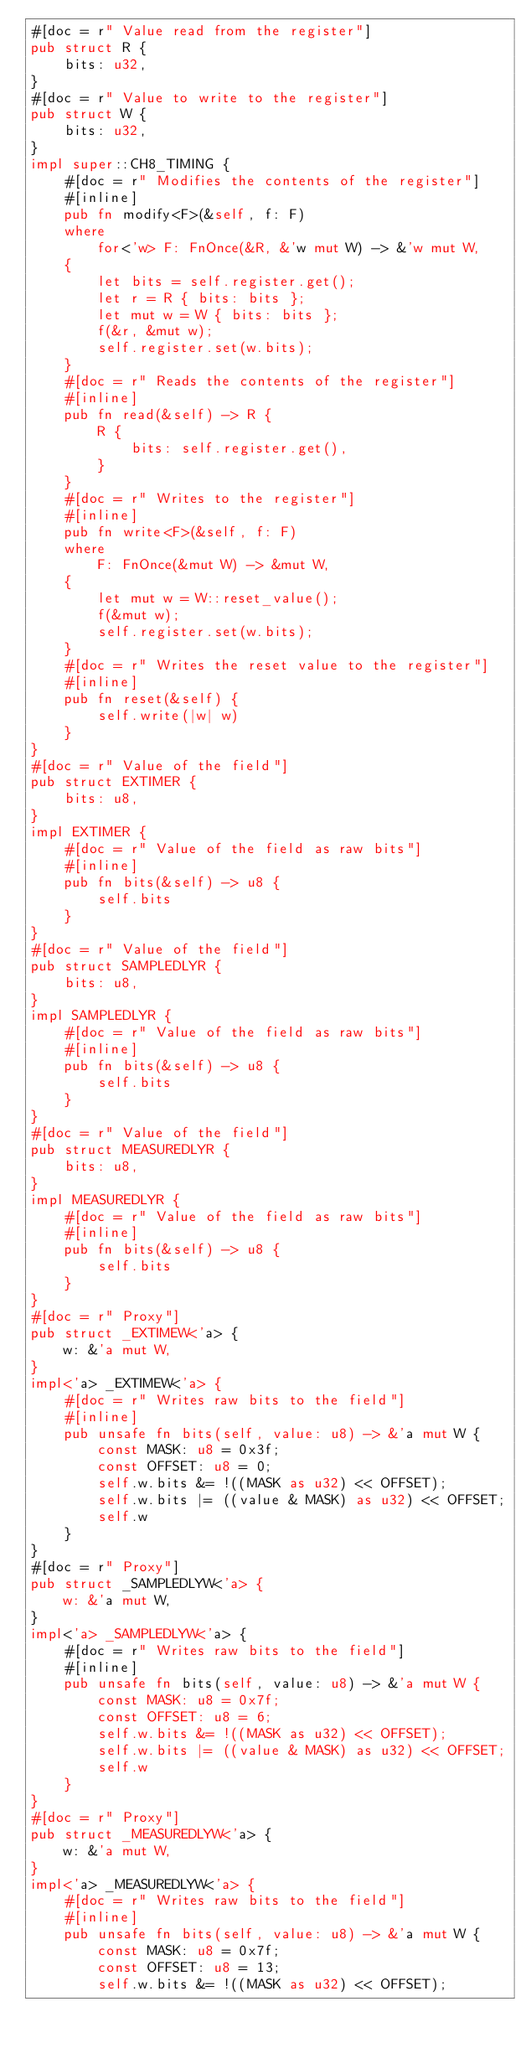Convert code to text. <code><loc_0><loc_0><loc_500><loc_500><_Rust_>#[doc = r" Value read from the register"]
pub struct R {
    bits: u32,
}
#[doc = r" Value to write to the register"]
pub struct W {
    bits: u32,
}
impl super::CH8_TIMING {
    #[doc = r" Modifies the contents of the register"]
    #[inline]
    pub fn modify<F>(&self, f: F)
    where
        for<'w> F: FnOnce(&R, &'w mut W) -> &'w mut W,
    {
        let bits = self.register.get();
        let r = R { bits: bits };
        let mut w = W { bits: bits };
        f(&r, &mut w);
        self.register.set(w.bits);
    }
    #[doc = r" Reads the contents of the register"]
    #[inline]
    pub fn read(&self) -> R {
        R {
            bits: self.register.get(),
        }
    }
    #[doc = r" Writes to the register"]
    #[inline]
    pub fn write<F>(&self, f: F)
    where
        F: FnOnce(&mut W) -> &mut W,
    {
        let mut w = W::reset_value();
        f(&mut w);
        self.register.set(w.bits);
    }
    #[doc = r" Writes the reset value to the register"]
    #[inline]
    pub fn reset(&self) {
        self.write(|w| w)
    }
}
#[doc = r" Value of the field"]
pub struct EXTIMER {
    bits: u8,
}
impl EXTIMER {
    #[doc = r" Value of the field as raw bits"]
    #[inline]
    pub fn bits(&self) -> u8 {
        self.bits
    }
}
#[doc = r" Value of the field"]
pub struct SAMPLEDLYR {
    bits: u8,
}
impl SAMPLEDLYR {
    #[doc = r" Value of the field as raw bits"]
    #[inline]
    pub fn bits(&self) -> u8 {
        self.bits
    }
}
#[doc = r" Value of the field"]
pub struct MEASUREDLYR {
    bits: u8,
}
impl MEASUREDLYR {
    #[doc = r" Value of the field as raw bits"]
    #[inline]
    pub fn bits(&self) -> u8 {
        self.bits
    }
}
#[doc = r" Proxy"]
pub struct _EXTIMEW<'a> {
    w: &'a mut W,
}
impl<'a> _EXTIMEW<'a> {
    #[doc = r" Writes raw bits to the field"]
    #[inline]
    pub unsafe fn bits(self, value: u8) -> &'a mut W {
        const MASK: u8 = 0x3f;
        const OFFSET: u8 = 0;
        self.w.bits &= !((MASK as u32) << OFFSET);
        self.w.bits |= ((value & MASK) as u32) << OFFSET;
        self.w
    }
}
#[doc = r" Proxy"]
pub struct _SAMPLEDLYW<'a> {
    w: &'a mut W,
}
impl<'a> _SAMPLEDLYW<'a> {
    #[doc = r" Writes raw bits to the field"]
    #[inline]
    pub unsafe fn bits(self, value: u8) -> &'a mut W {
        const MASK: u8 = 0x7f;
        const OFFSET: u8 = 6;
        self.w.bits &= !((MASK as u32) << OFFSET);
        self.w.bits |= ((value & MASK) as u32) << OFFSET;
        self.w
    }
}
#[doc = r" Proxy"]
pub struct _MEASUREDLYW<'a> {
    w: &'a mut W,
}
impl<'a> _MEASUREDLYW<'a> {
    #[doc = r" Writes raw bits to the field"]
    #[inline]
    pub unsafe fn bits(self, value: u8) -> &'a mut W {
        const MASK: u8 = 0x7f;
        const OFFSET: u8 = 13;
        self.w.bits &= !((MASK as u32) << OFFSET);</code> 